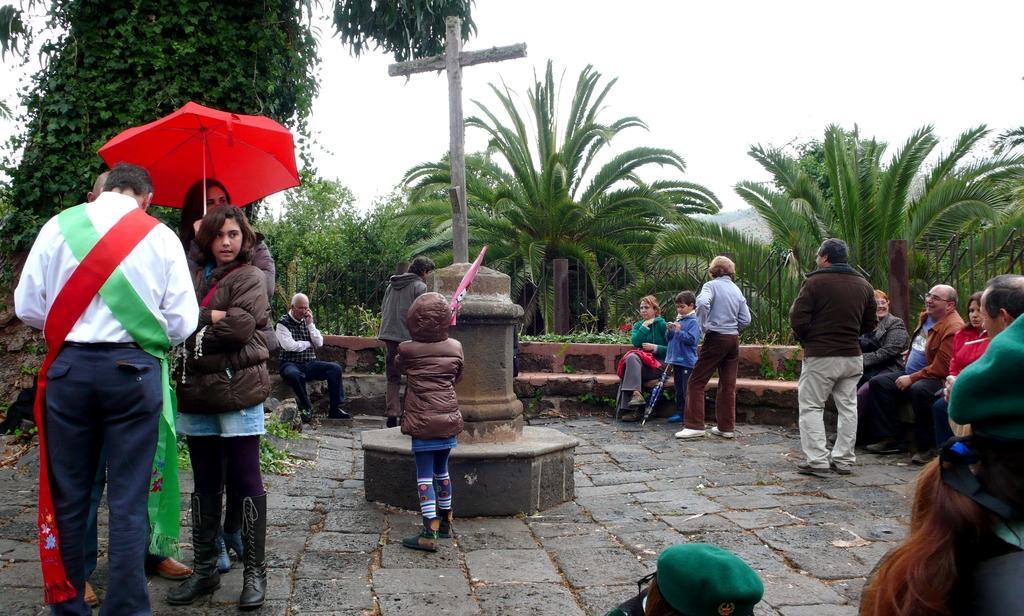In one or two sentences, can you explain what this image depicts? In the picture we can see a path with rock tiles and in the middle we can see a stone with a cross on it and around it we can see some people are standing and some are sitting on the bench and one woman is standing and holding an umbrella which is red in color and in the background we can see plants, trees and sky. 